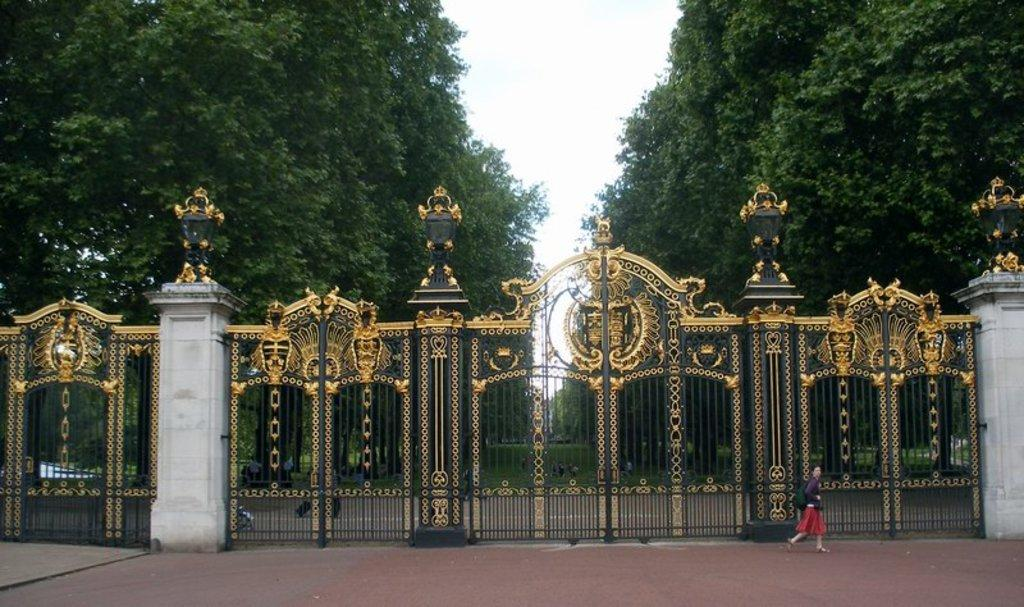What is the person in the image carrying? The person in the image is carrying a backpack. What is the person doing in the image? The person is walking on the road. What can be seen in the background of the image? There is a big gate, grass, trees, and the sky visible in the background of the image. What type of plant is the person saying good-bye to in the image? There is no plant or good-bye gesture present in the image. Is there a cart being pulled by the person in the image? No, there is no cart present in the image. 